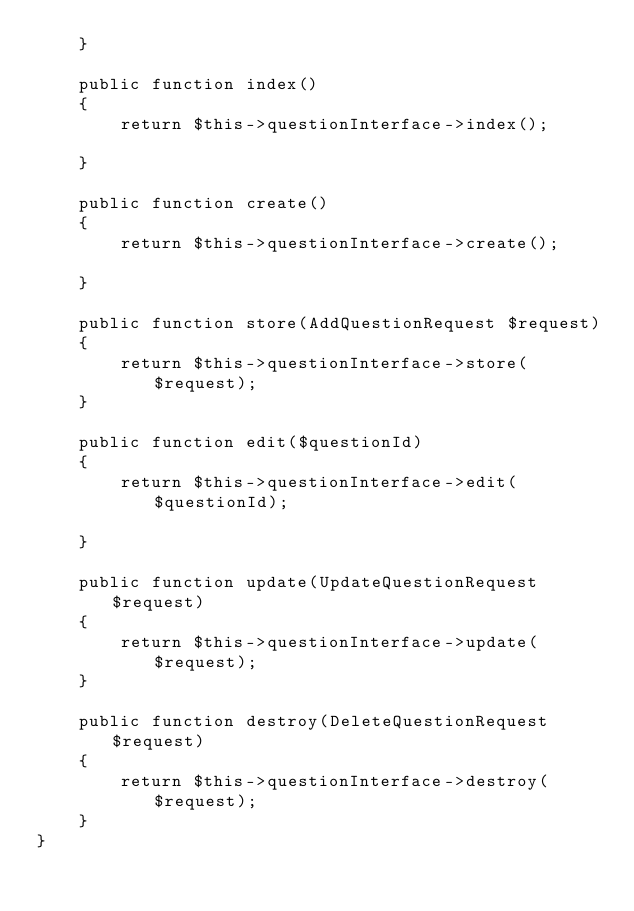<code> <loc_0><loc_0><loc_500><loc_500><_PHP_>    }

    public function index()
    {
        return $this->questionInterface->index();

    }

    public function create()
    {
        return $this->questionInterface->create();

    }

    public function store(AddQuestionRequest $request)
    {
        return $this->questionInterface->store($request);
    }

    public function edit($questionId)
    {
        return $this->questionInterface->edit($questionId);

    }

    public function update(UpdateQuestionRequest $request)
    {
        return $this->questionInterface->update($request);
    }

    public function destroy(DeleteQuestionRequest $request)
    {
        return $this->questionInterface->destroy($request);
    }
}
</code> 